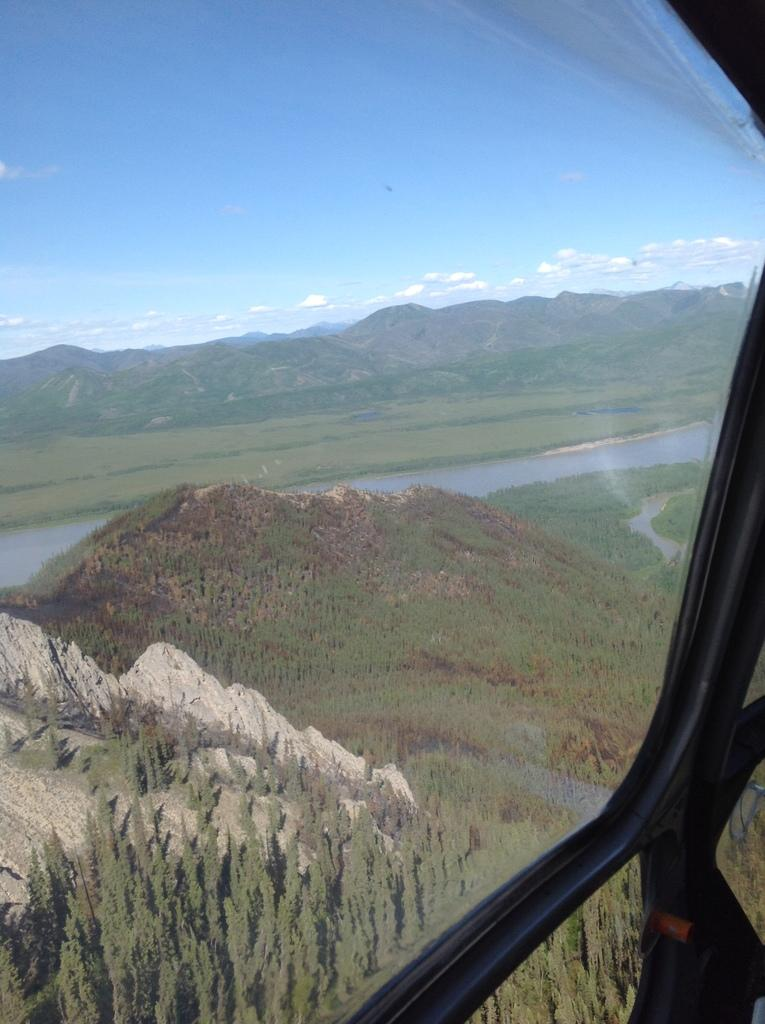What is the perspective of the image? The image is taken from a helicopter. What type of geographical features can be seen in the image? There are mountains, trees, and a river in the image. What part of the natural environment is visible in the image? The sky is visible in the image. What type of cork can be seen floating in the river in the image? There is no cork present in the image; it only features mountains, trees, a river, and the sky. 